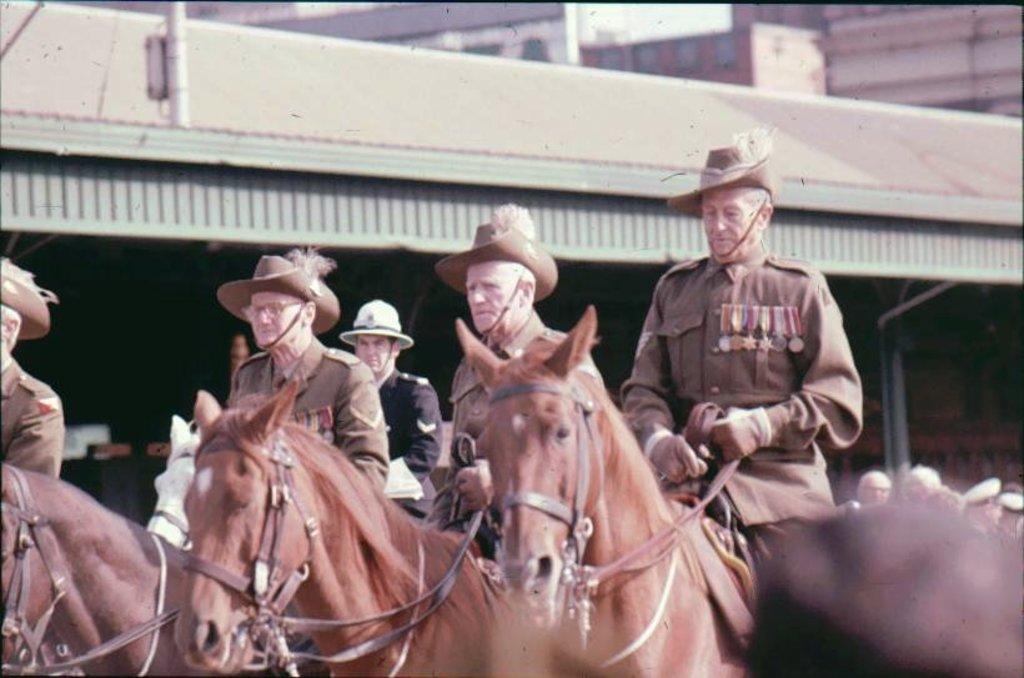Could you give a brief overview of what you see in this image? In this picture some people riding a horse and in the background there are some buildings 